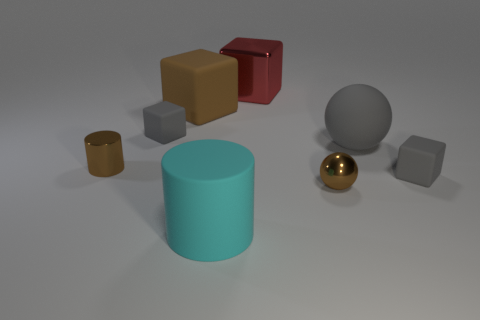Is the color of the metal ball the same as the shiny cylinder?
Make the answer very short. Yes. What shape is the big brown object that is the same material as the cyan cylinder?
Make the answer very short. Cube. How many gray rubber things are the same shape as the large red metallic object?
Your answer should be very brief. 2. There is a tiny gray thing that is on the right side of the small cube that is on the left side of the brown rubber block; what is its shape?
Make the answer very short. Cube. There is a brown thing right of the red block; is it the same size as the big red shiny object?
Offer a terse response. No. What size is the matte object that is both behind the large cylinder and in front of the small metallic cylinder?
Offer a very short reply. Small. How many cyan rubber cylinders are the same size as the gray rubber ball?
Provide a short and direct response. 1. What number of shiny cubes are left of the rubber object that is left of the large brown object?
Offer a terse response. 0. Does the cylinder to the left of the large cyan matte object have the same color as the metal ball?
Provide a succinct answer. Yes. There is a big block behind the large block that is on the left side of the cyan matte cylinder; are there any small gray cubes that are left of it?
Provide a short and direct response. Yes. 